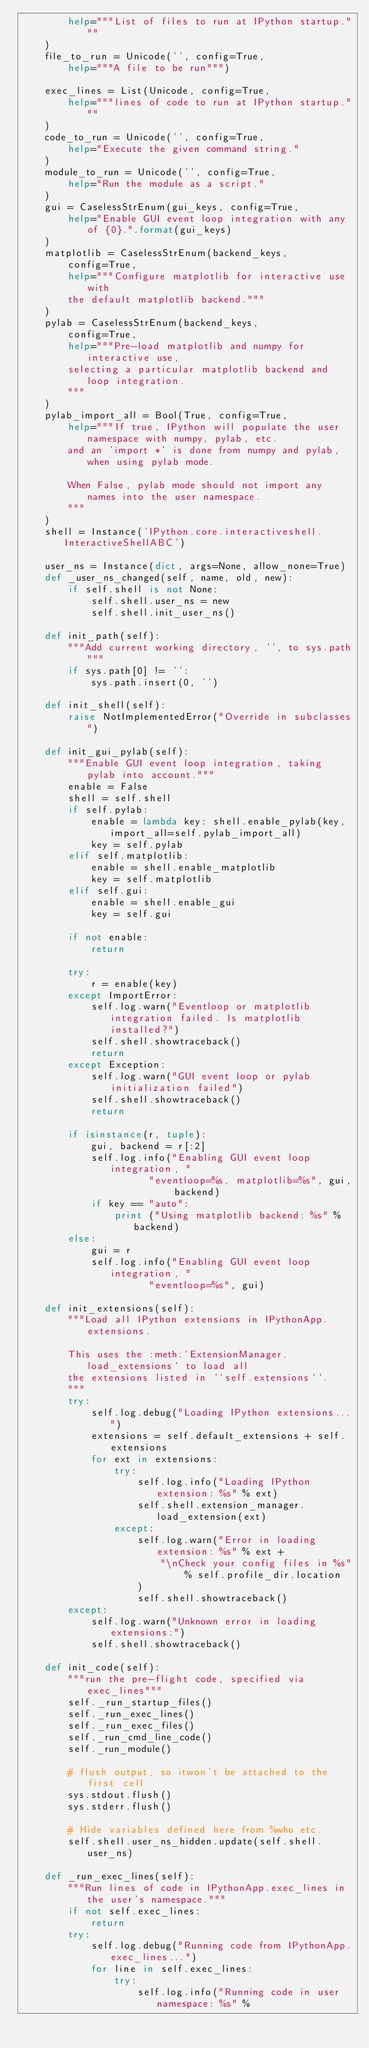<code> <loc_0><loc_0><loc_500><loc_500><_Python_>        help="""List of files to run at IPython startup."""
    )
    file_to_run = Unicode('', config=True,
        help="""A file to be run""")

    exec_lines = List(Unicode, config=True,
        help="""lines of code to run at IPython startup."""
    )
    code_to_run = Unicode('', config=True,
        help="Execute the given command string."
    )
    module_to_run = Unicode('', config=True,
        help="Run the module as a script."
    )
    gui = CaselessStrEnum(gui_keys, config=True,
        help="Enable GUI event loop integration with any of {0}.".format(gui_keys)
    )
    matplotlib = CaselessStrEnum(backend_keys,
        config=True,
        help="""Configure matplotlib for interactive use with
        the default matplotlib backend."""
    )
    pylab = CaselessStrEnum(backend_keys,
        config=True,
        help="""Pre-load matplotlib and numpy for interactive use,
        selecting a particular matplotlib backend and loop integration.
        """
    )
    pylab_import_all = Bool(True, config=True,
        help="""If true, IPython will populate the user namespace with numpy, pylab, etc.
        and an 'import *' is done from numpy and pylab, when using pylab mode.
        
        When False, pylab mode should not import any names into the user namespace.
        """
    )
    shell = Instance('IPython.core.interactiveshell.InteractiveShellABC')
    
    user_ns = Instance(dict, args=None, allow_none=True)
    def _user_ns_changed(self, name, old, new):
        if self.shell is not None:
            self.shell.user_ns = new
            self.shell.init_user_ns()

    def init_path(self):
        """Add current working directory, '', to sys.path"""
        if sys.path[0] != '':
            sys.path.insert(0, '')

    def init_shell(self):
        raise NotImplementedError("Override in subclasses")

    def init_gui_pylab(self):
        """Enable GUI event loop integration, taking pylab into account."""
        enable = False
        shell = self.shell
        if self.pylab:
            enable = lambda key: shell.enable_pylab(key, import_all=self.pylab_import_all)
            key = self.pylab
        elif self.matplotlib:
            enable = shell.enable_matplotlib
            key = self.matplotlib
        elif self.gui:
            enable = shell.enable_gui
            key = self.gui
        
        if not enable:
            return
        
        try:
            r = enable(key)
        except ImportError:
            self.log.warn("Eventloop or matplotlib integration failed. Is matplotlib installed?")
            self.shell.showtraceback()
            return
        except Exception:
            self.log.warn("GUI event loop or pylab initialization failed")
            self.shell.showtraceback()
            return
            
        if isinstance(r, tuple):
            gui, backend = r[:2]
            self.log.info("Enabling GUI event loop integration, "
                      "eventloop=%s, matplotlib=%s", gui, backend)
            if key == "auto":
                print ("Using matplotlib backend: %s" % backend)
        else:
            gui = r
            self.log.info("Enabling GUI event loop integration, "
                      "eventloop=%s", gui)

    def init_extensions(self):
        """Load all IPython extensions in IPythonApp.extensions.

        This uses the :meth:`ExtensionManager.load_extensions` to load all
        the extensions listed in ``self.extensions``.
        """
        try:
            self.log.debug("Loading IPython extensions...")
            extensions = self.default_extensions + self.extensions
            for ext in extensions:
                try:
                    self.log.info("Loading IPython extension: %s" % ext)
                    self.shell.extension_manager.load_extension(ext)
                except:
                    self.log.warn("Error in loading extension: %s" % ext +
                        "\nCheck your config files in %s" % self.profile_dir.location
                    )
                    self.shell.showtraceback()
        except:
            self.log.warn("Unknown error in loading extensions:")
            self.shell.showtraceback()

    def init_code(self):
        """run the pre-flight code, specified via exec_lines"""
        self._run_startup_files()
        self._run_exec_lines()
        self._run_exec_files()
        self._run_cmd_line_code()
        self._run_module()
        
        # flush output, so itwon't be attached to the first cell
        sys.stdout.flush()
        sys.stderr.flush()
        
        # Hide variables defined here from %who etc.
        self.shell.user_ns_hidden.update(self.shell.user_ns)

    def _run_exec_lines(self):
        """Run lines of code in IPythonApp.exec_lines in the user's namespace."""
        if not self.exec_lines:
            return
        try:
            self.log.debug("Running code from IPythonApp.exec_lines...")
            for line in self.exec_lines:
                try:
                    self.log.info("Running code in user namespace: %s" %</code> 